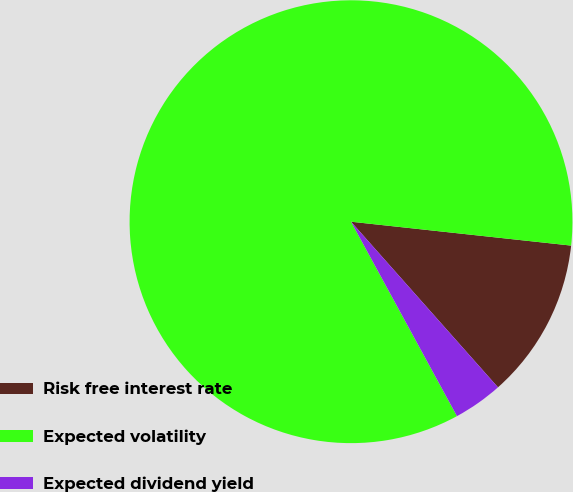Convert chart to OTSL. <chart><loc_0><loc_0><loc_500><loc_500><pie_chart><fcel>Risk free interest rate<fcel>Expected volatility<fcel>Expected dividend yield<nl><fcel>11.73%<fcel>84.67%<fcel>3.61%<nl></chart> 